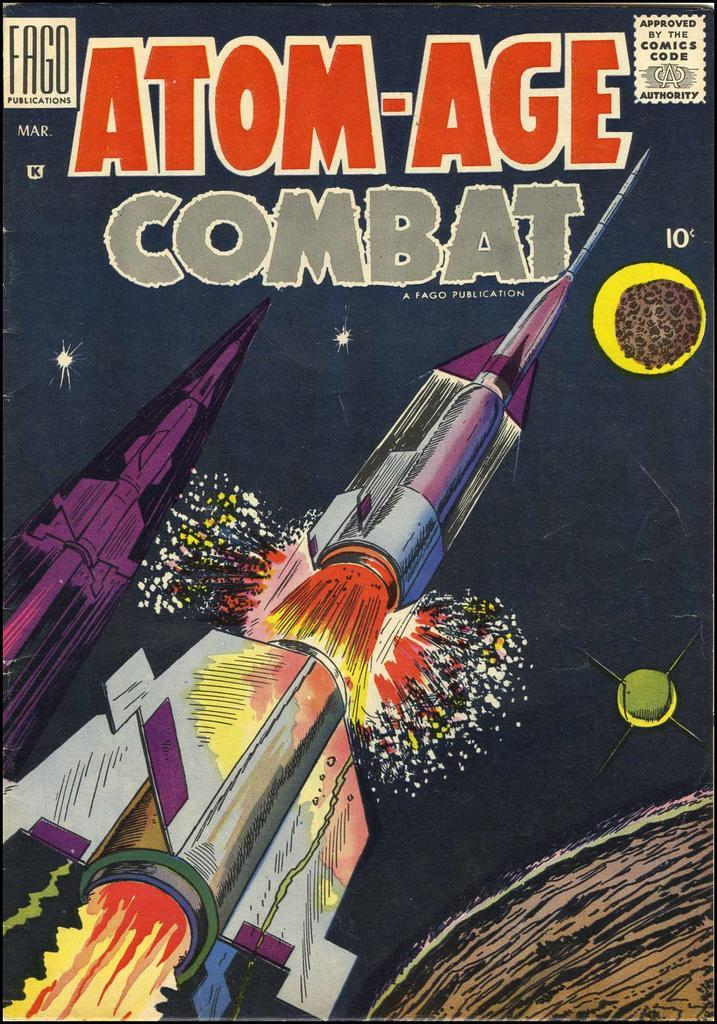<image>
Render a clear and concise summary of the photo. A Fago Publications comic titled Atom-Age Combat has a rocket on it. 